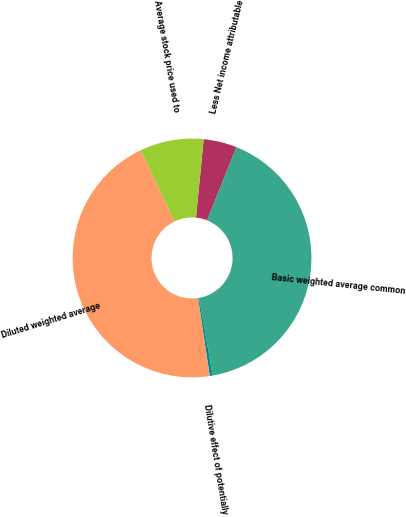Convert chart. <chart><loc_0><loc_0><loc_500><loc_500><pie_chart><fcel>Less Net income attributable<fcel>Basic weighted average common<fcel>Dilutive effect of potentially<fcel>Diluted weighted average<fcel>Average stock price used to<nl><fcel>4.51%<fcel>41.17%<fcel>0.4%<fcel>45.29%<fcel>8.63%<nl></chart> 